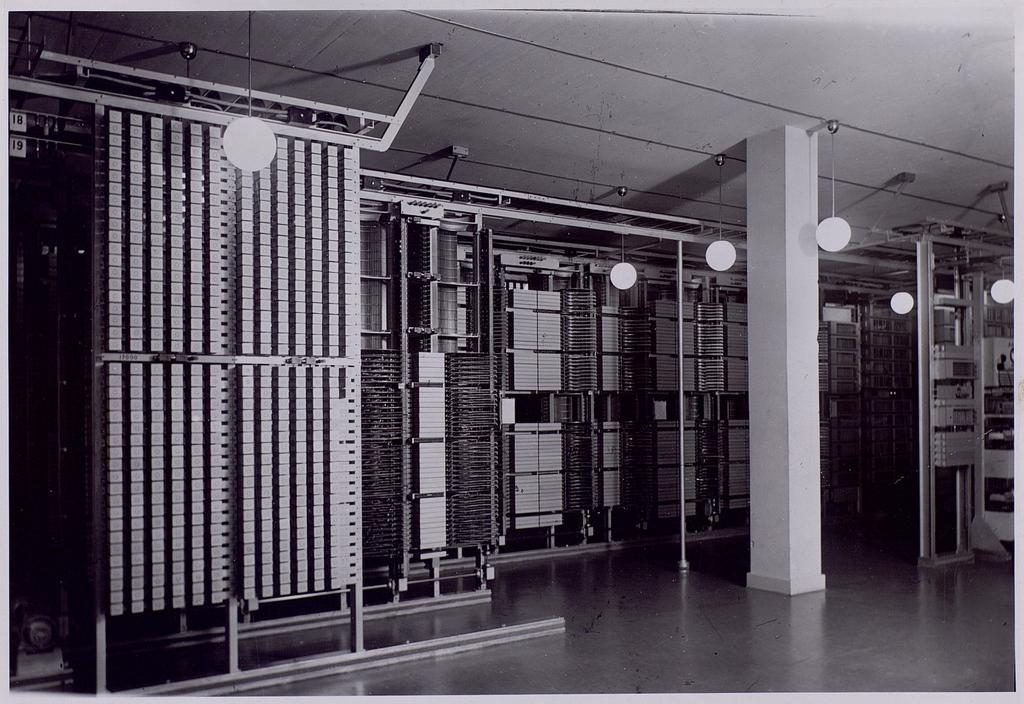Could you give a brief overview of what you see in this image? Here in this picture we can see shelves present all over there, which are filled with some things and we can see light hanging on the roof here and there and in the middle we can see pillar present over there. 